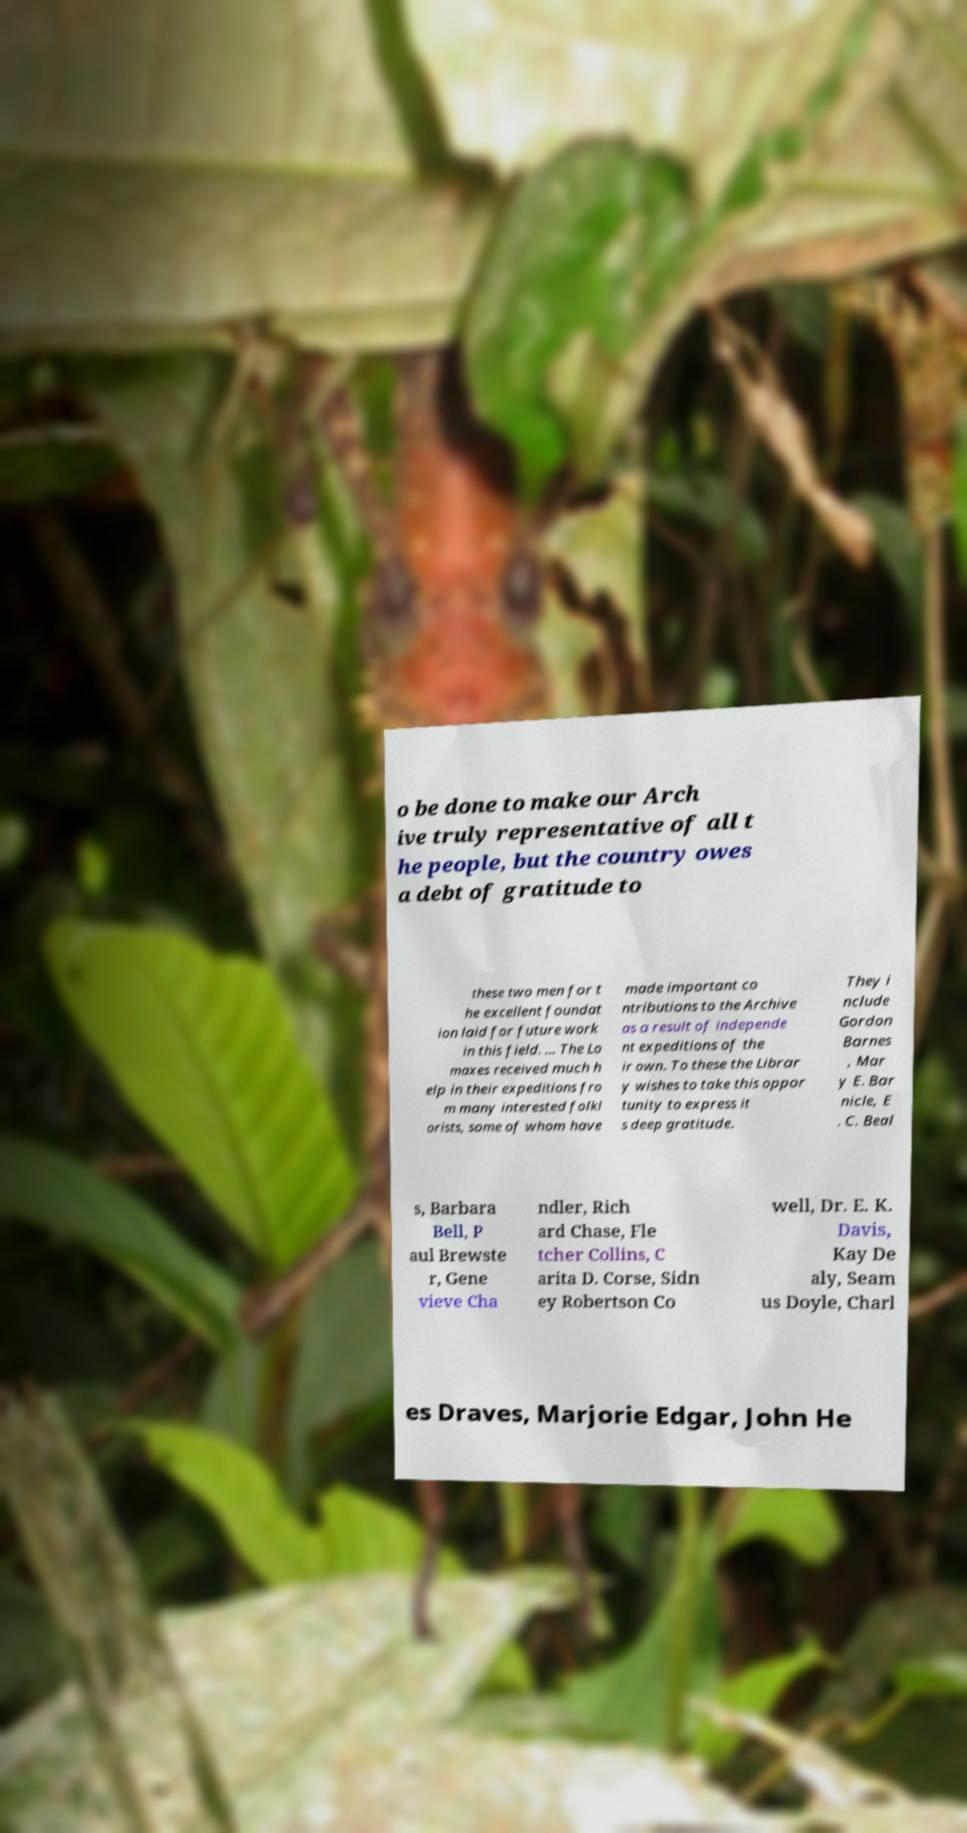Could you extract and type out the text from this image? o be done to make our Arch ive truly representative of all t he people, but the country owes a debt of gratitude to these two men for t he excellent foundat ion laid for future work in this field. ... The Lo maxes received much h elp in their expeditions fro m many interested folkl orists, some of whom have made important co ntributions to the Archive as a result of independe nt expeditions of the ir own. To these the Librar y wishes to take this oppor tunity to express it s deep gratitude. They i nclude Gordon Barnes , Mar y E. Bar nicle, E . C. Beal s, Barbara Bell, P aul Brewste r, Gene vieve Cha ndler, Rich ard Chase, Fle tcher Collins, C arita D. Corse, Sidn ey Robertson Co well, Dr. E. K. Davis, Kay De aly, Seam us Doyle, Charl es Draves, Marjorie Edgar, John He 